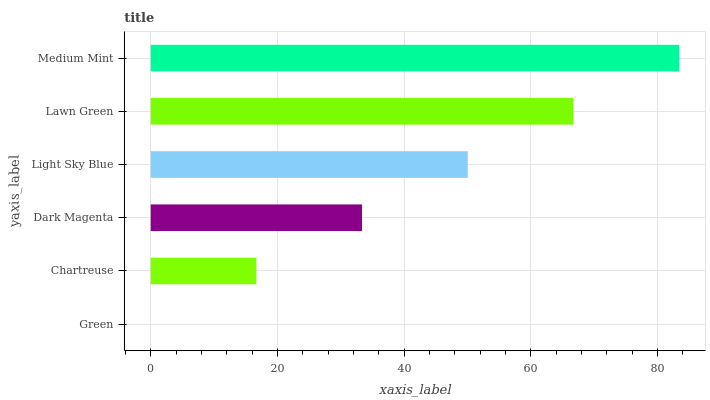Is Green the minimum?
Answer yes or no. Yes. Is Medium Mint the maximum?
Answer yes or no. Yes. Is Chartreuse the minimum?
Answer yes or no. No. Is Chartreuse the maximum?
Answer yes or no. No. Is Chartreuse greater than Green?
Answer yes or no. Yes. Is Green less than Chartreuse?
Answer yes or no. Yes. Is Green greater than Chartreuse?
Answer yes or no. No. Is Chartreuse less than Green?
Answer yes or no. No. Is Light Sky Blue the high median?
Answer yes or no. Yes. Is Dark Magenta the low median?
Answer yes or no. Yes. Is Lawn Green the high median?
Answer yes or no. No. Is Medium Mint the low median?
Answer yes or no. No. 